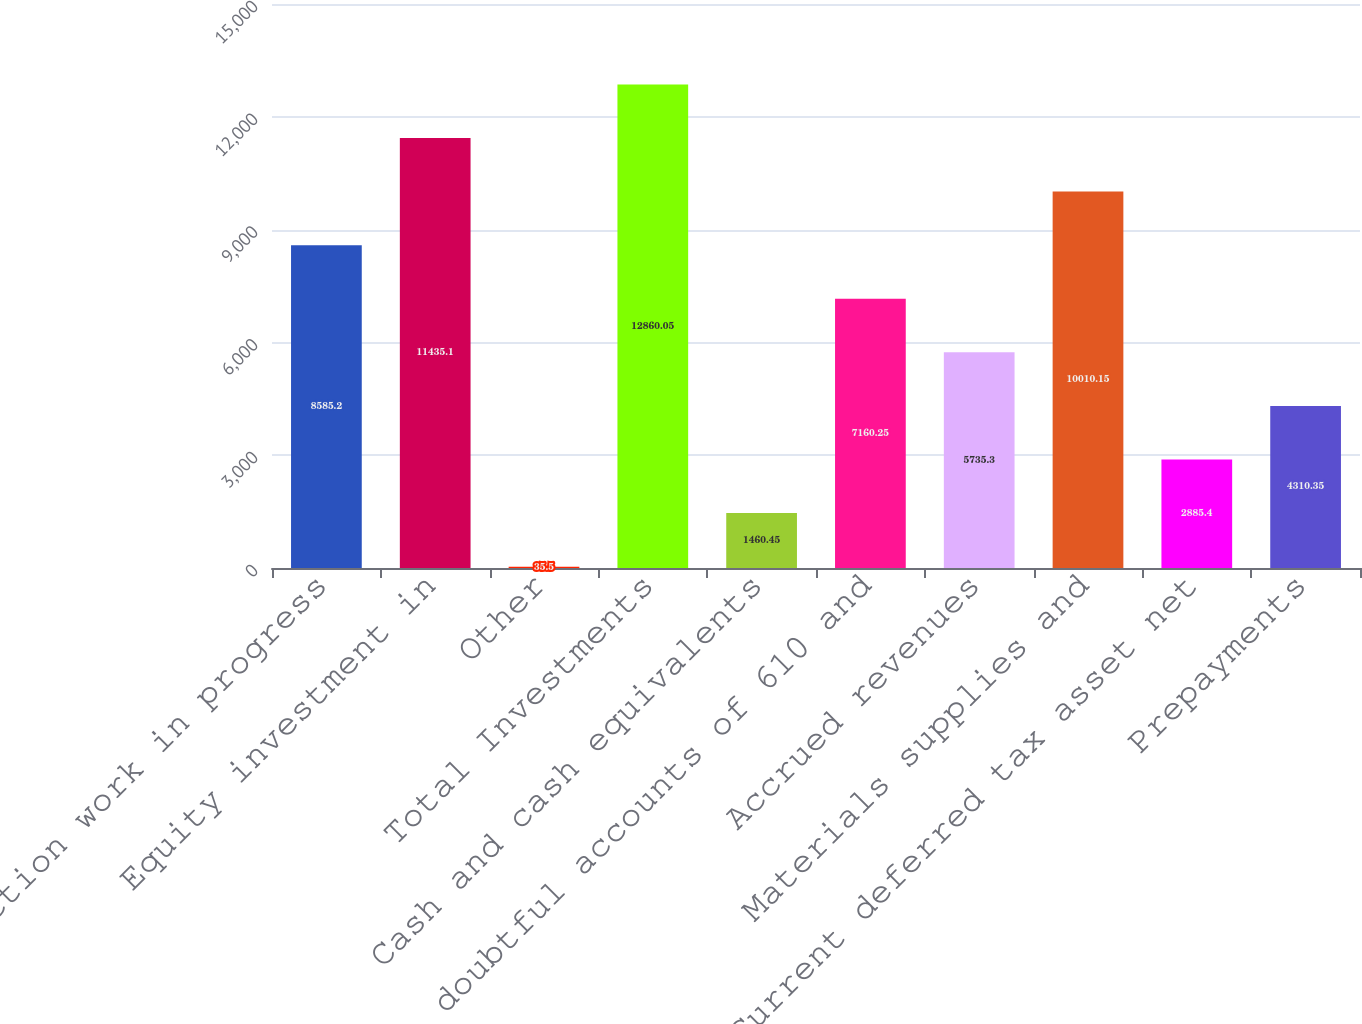Convert chart. <chart><loc_0><loc_0><loc_500><loc_500><bar_chart><fcel>Construction work in progress<fcel>Equity investment in<fcel>Other<fcel>Total Investments<fcel>Cash and cash equivalents<fcel>doubtful accounts of 610 and<fcel>Accrued revenues<fcel>Materials supplies and<fcel>Current deferred tax asset net<fcel>Prepayments<nl><fcel>8585.2<fcel>11435.1<fcel>35.5<fcel>12860<fcel>1460.45<fcel>7160.25<fcel>5735.3<fcel>10010.1<fcel>2885.4<fcel>4310.35<nl></chart> 